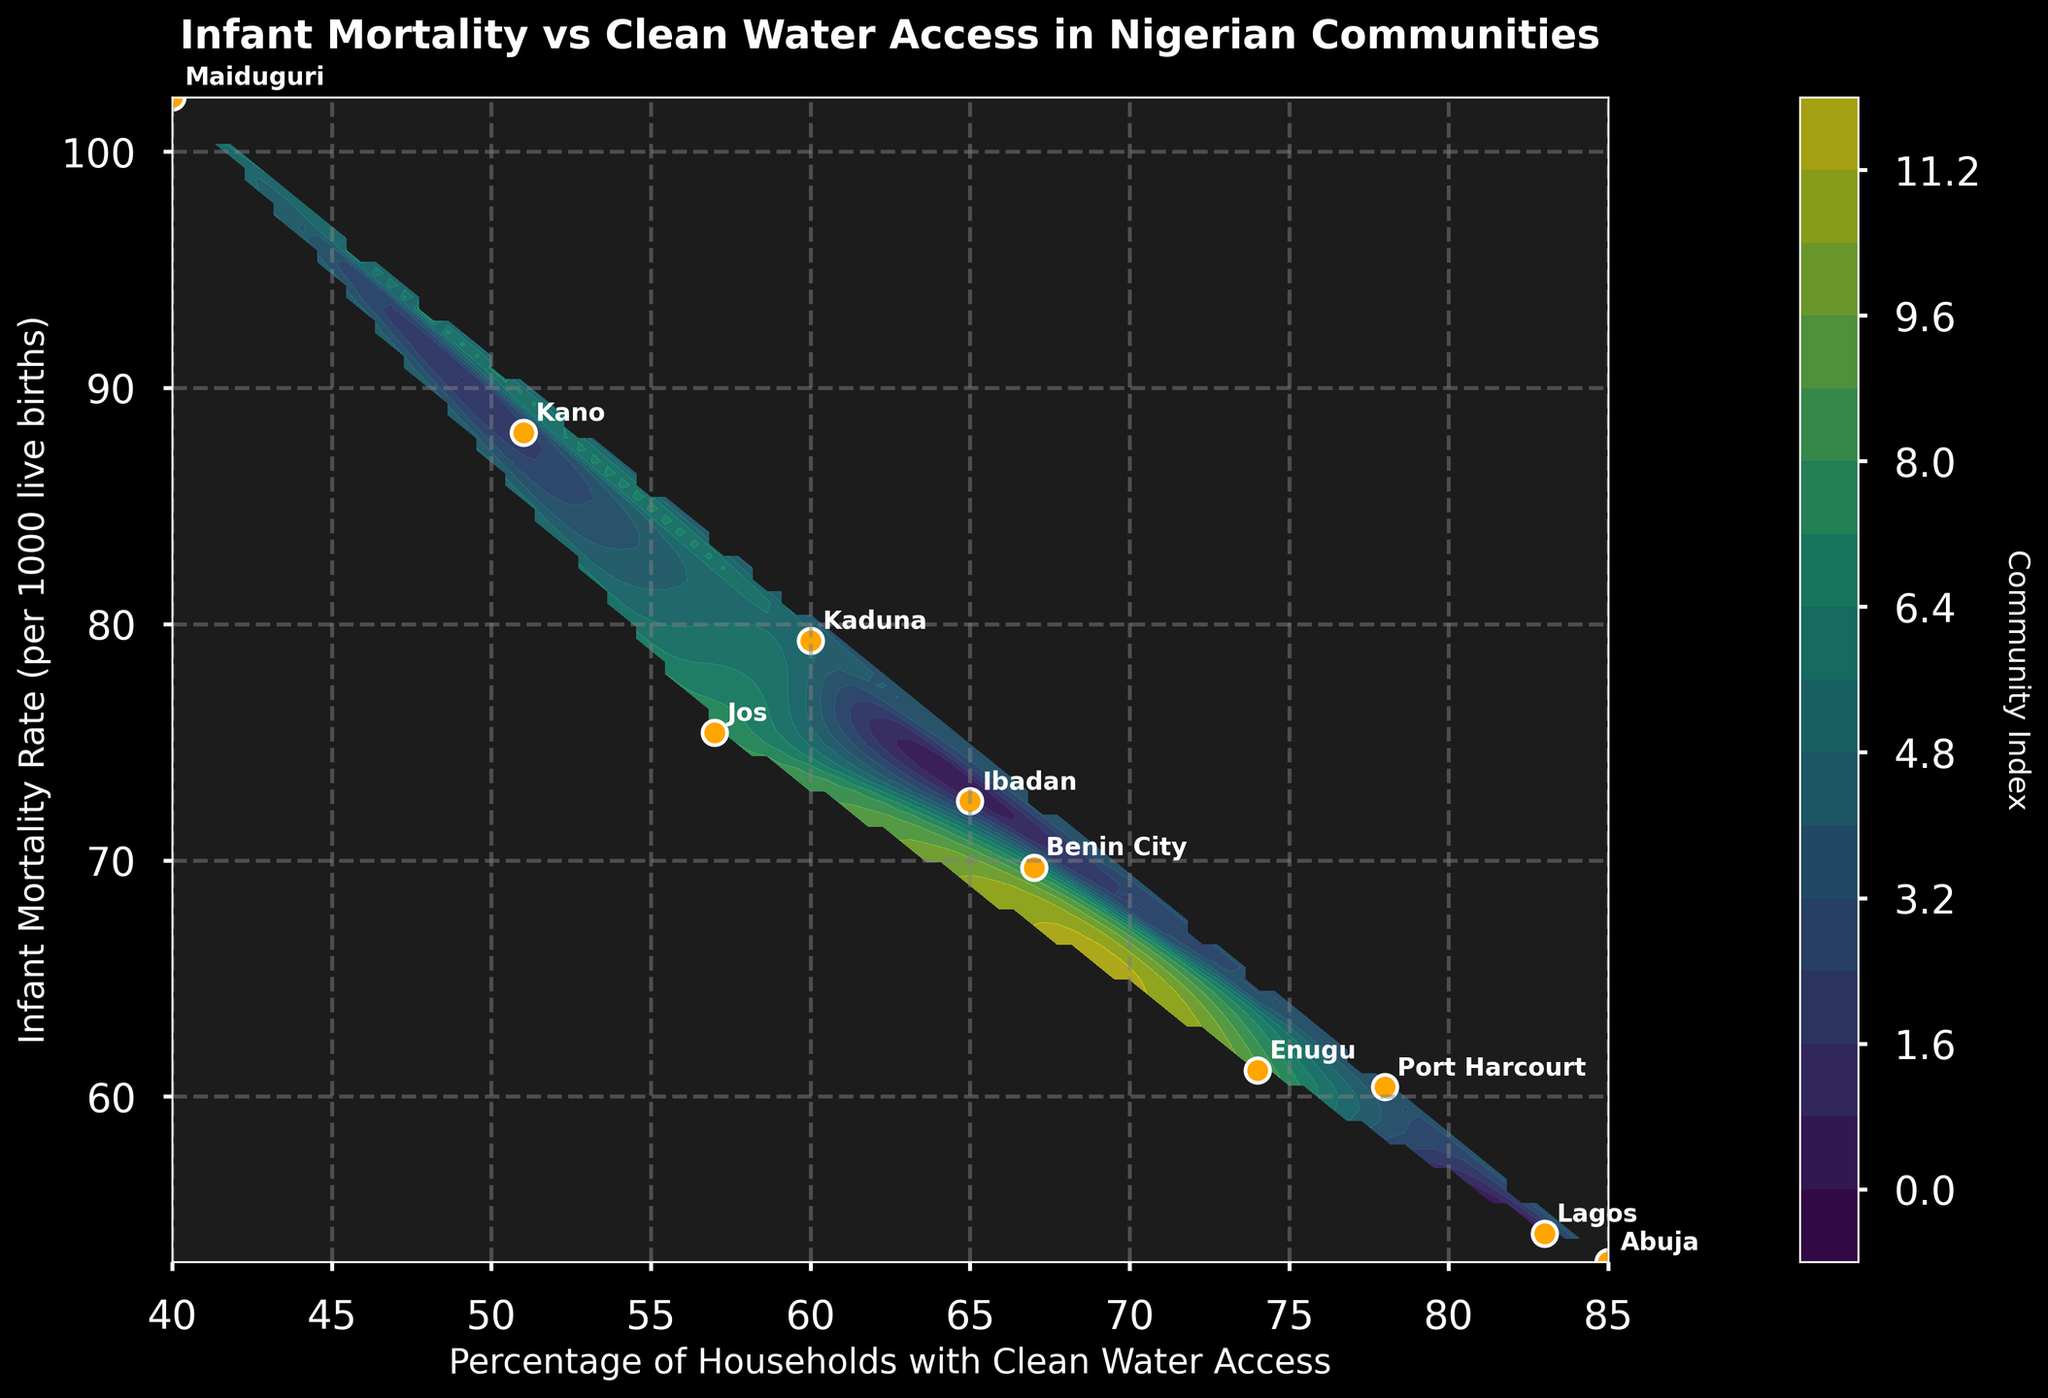What is the title of the plot? The title of the plot is located at the top of the figure, written in a larger font than the rest of the labels. By looking at this, we can directly read the title.
Answer: Infant Mortality vs Clean Water Access in Nigerian Communities How many communities are represented in the plot? By counting the number of labeled points (annotations) in the plot, you can determine the number of communities being represented.
Answer: 10 Which community has the highest infant mortality rate? Look for the point that is the highest on the y-axis labeled "Infant Mortality Rate (per 1000 live births)" and read the community name next to it.
Answer: Maiduguri Which community has the lowest percentage of households with clean water access? Identify the point that is the furthest left on the x-axis labeled "Percentage of Households with Clean Water Access" and read the community's name next to it.
Answer: Maiduguri What is the color of the contour where Lagos is located, and what does it represent? Find Lagos on the scatter plot, then observe the color of the contour that surrounds it. Use the color bar to determine the community index represented by that color.
Answer: Greenish area, representing a lower community index How do the percentages of households with clean water access for Jos and Abuja compare? Find the x-axis values for both Jos and Abuja and compare the numerical values to see which one is higher.
Answer: Abuja has a higher percentage Which community has the closest infant mortality rate to 60 per 1000 live births? Look for the point(s) near the y-axis value of 60 and check the closest community label.
Answer: Port Harcourt and Enugu Rank the communities from highest to lowest in terms of infant mortality rate. List the communities by consecutively checking the y-axis values from the highest number to the lowest and noting the corresponding community label.
Answer: Maiduguri, Kano, Kaduna, Jos, Ibadan, Benin City, Enugu, Port Harcourt, Lagos, Abuja Identify one insight you can gather from the relationship between clean water access and infant mortality based on this plot. By observing the trend of the points in the scattered plot, note that communities with higher percentages of clean water access tend to show lower infant mortality rates.
Answer: More clean water access correlates with lower infant mortality rates Between Enugu and Benin City, which has a higher community index on the contour? Locate both Enugu and Benin City on the plot and compare their surrounding contour colors using the color bar to determine the community index.
Answer: Benin City 